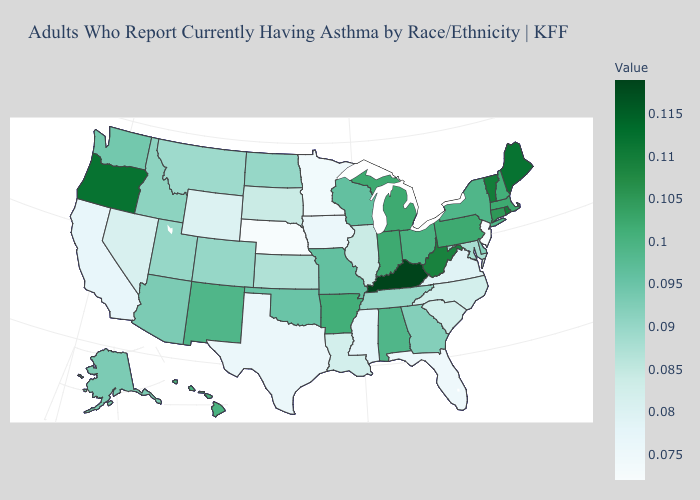Does the map have missing data?
Concise answer only. No. Which states hav the highest value in the West?
Give a very brief answer. Oregon. Among the states that border Kansas , does Nebraska have the lowest value?
Give a very brief answer. Yes. Which states have the lowest value in the USA?
Answer briefly. Nebraska, New Jersey. 